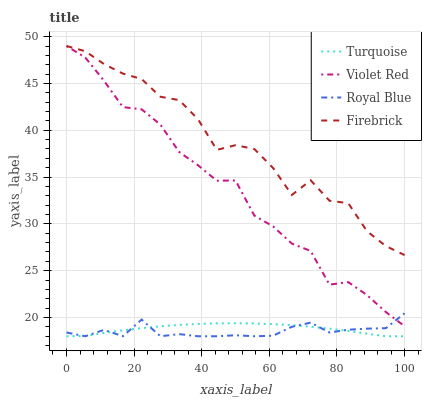Does Royal Blue have the minimum area under the curve?
Answer yes or no. Yes. Does Firebrick have the maximum area under the curve?
Answer yes or no. Yes. Does Turquoise have the minimum area under the curve?
Answer yes or no. No. Does Turquoise have the maximum area under the curve?
Answer yes or no. No. Is Turquoise the smoothest?
Answer yes or no. Yes. Is Firebrick the roughest?
Answer yes or no. Yes. Is Firebrick the smoothest?
Answer yes or no. No. Is Turquoise the roughest?
Answer yes or no. No. Does Royal Blue have the lowest value?
Answer yes or no. Yes. Does Firebrick have the lowest value?
Answer yes or no. No. Does Violet Red have the highest value?
Answer yes or no. Yes. Does Turquoise have the highest value?
Answer yes or no. No. Is Turquoise less than Firebrick?
Answer yes or no. Yes. Is Violet Red greater than Turquoise?
Answer yes or no. Yes. Does Royal Blue intersect Violet Red?
Answer yes or no. Yes. Is Royal Blue less than Violet Red?
Answer yes or no. No. Is Royal Blue greater than Violet Red?
Answer yes or no. No. Does Turquoise intersect Firebrick?
Answer yes or no. No. 